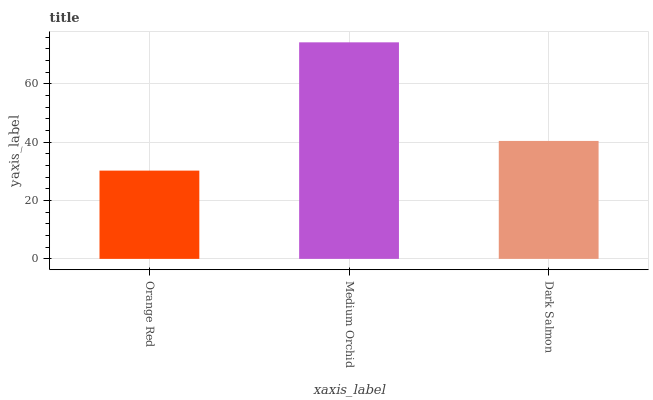Is Orange Red the minimum?
Answer yes or no. Yes. Is Medium Orchid the maximum?
Answer yes or no. Yes. Is Dark Salmon the minimum?
Answer yes or no. No. Is Dark Salmon the maximum?
Answer yes or no. No. Is Medium Orchid greater than Dark Salmon?
Answer yes or no. Yes. Is Dark Salmon less than Medium Orchid?
Answer yes or no. Yes. Is Dark Salmon greater than Medium Orchid?
Answer yes or no. No. Is Medium Orchid less than Dark Salmon?
Answer yes or no. No. Is Dark Salmon the high median?
Answer yes or no. Yes. Is Dark Salmon the low median?
Answer yes or no. Yes. Is Medium Orchid the high median?
Answer yes or no. No. Is Medium Orchid the low median?
Answer yes or no. No. 